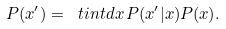Convert formula to latex. <formula><loc_0><loc_0><loc_500><loc_500>P ( x ^ { \prime } ) = \ t i n t d x \, P ( x ^ { \prime } | x ) P ( x ) .</formula> 